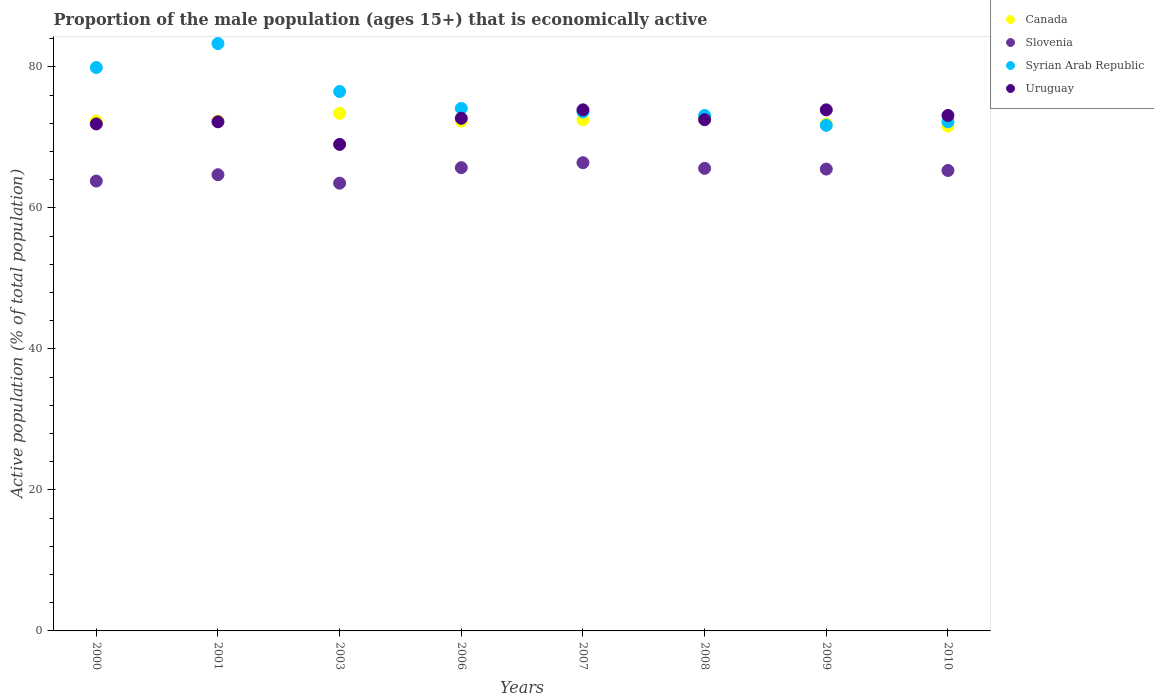Is the number of dotlines equal to the number of legend labels?
Offer a very short reply. Yes. What is the proportion of the male population that is economically active in Slovenia in 2006?
Your answer should be very brief. 65.7. Across all years, what is the maximum proportion of the male population that is economically active in Canada?
Provide a short and direct response. 73.4. Across all years, what is the minimum proportion of the male population that is economically active in Syrian Arab Republic?
Make the answer very short. 71.7. In which year was the proportion of the male population that is economically active in Uruguay minimum?
Your answer should be compact. 2003. What is the total proportion of the male population that is economically active in Slovenia in the graph?
Offer a very short reply. 520.5. What is the difference between the proportion of the male population that is economically active in Uruguay in 2000 and that in 2007?
Keep it short and to the point. -2. What is the difference between the proportion of the male population that is economically active in Uruguay in 2003 and the proportion of the male population that is economically active in Syrian Arab Republic in 2000?
Give a very brief answer. -10.9. What is the average proportion of the male population that is economically active in Syrian Arab Republic per year?
Your answer should be compact. 75.55. In the year 2007, what is the difference between the proportion of the male population that is economically active in Canada and proportion of the male population that is economically active in Uruguay?
Your answer should be compact. -1.4. What is the ratio of the proportion of the male population that is economically active in Slovenia in 2000 to that in 2003?
Your response must be concise. 1. What is the difference between the highest and the second highest proportion of the male population that is economically active in Syrian Arab Republic?
Offer a very short reply. 3.4. What is the difference between the highest and the lowest proportion of the male population that is economically active in Slovenia?
Your answer should be very brief. 2.9. In how many years, is the proportion of the male population that is economically active in Canada greater than the average proportion of the male population that is economically active in Canada taken over all years?
Ensure brevity in your answer.  3. Is the sum of the proportion of the male population that is economically active in Syrian Arab Republic in 2001 and 2007 greater than the maximum proportion of the male population that is economically active in Slovenia across all years?
Your response must be concise. Yes. Is it the case that in every year, the sum of the proportion of the male population that is economically active in Syrian Arab Republic and proportion of the male population that is economically active in Slovenia  is greater than the sum of proportion of the male population that is economically active in Canada and proportion of the male population that is economically active in Uruguay?
Your answer should be very brief. No. Is it the case that in every year, the sum of the proportion of the male population that is economically active in Syrian Arab Republic and proportion of the male population that is economically active in Uruguay  is greater than the proportion of the male population that is economically active in Canada?
Your response must be concise. Yes. Does the proportion of the male population that is economically active in Canada monotonically increase over the years?
Ensure brevity in your answer.  No. How many dotlines are there?
Offer a very short reply. 4. How many years are there in the graph?
Ensure brevity in your answer.  8. Are the values on the major ticks of Y-axis written in scientific E-notation?
Make the answer very short. No. Does the graph contain any zero values?
Give a very brief answer. No. How many legend labels are there?
Your answer should be very brief. 4. How are the legend labels stacked?
Provide a short and direct response. Vertical. What is the title of the graph?
Make the answer very short. Proportion of the male population (ages 15+) that is economically active. Does "Mauritania" appear as one of the legend labels in the graph?
Offer a terse response. No. What is the label or title of the Y-axis?
Provide a short and direct response. Active population (% of total population). What is the Active population (% of total population) of Canada in 2000?
Offer a terse response. 72.3. What is the Active population (% of total population) of Slovenia in 2000?
Offer a very short reply. 63.8. What is the Active population (% of total population) of Syrian Arab Republic in 2000?
Keep it short and to the point. 79.9. What is the Active population (% of total population) of Uruguay in 2000?
Make the answer very short. 71.9. What is the Active population (% of total population) in Canada in 2001?
Your answer should be very brief. 72.3. What is the Active population (% of total population) in Slovenia in 2001?
Keep it short and to the point. 64.7. What is the Active population (% of total population) in Syrian Arab Republic in 2001?
Make the answer very short. 83.3. What is the Active population (% of total population) of Uruguay in 2001?
Keep it short and to the point. 72.2. What is the Active population (% of total population) in Canada in 2003?
Make the answer very short. 73.4. What is the Active population (% of total population) of Slovenia in 2003?
Ensure brevity in your answer.  63.5. What is the Active population (% of total population) of Syrian Arab Republic in 2003?
Give a very brief answer. 76.5. What is the Active population (% of total population) in Uruguay in 2003?
Offer a very short reply. 69. What is the Active population (% of total population) of Canada in 2006?
Make the answer very short. 72.3. What is the Active population (% of total population) in Slovenia in 2006?
Your answer should be very brief. 65.7. What is the Active population (% of total population) in Syrian Arab Republic in 2006?
Offer a terse response. 74.1. What is the Active population (% of total population) in Uruguay in 2006?
Give a very brief answer. 72.7. What is the Active population (% of total population) of Canada in 2007?
Offer a very short reply. 72.5. What is the Active population (% of total population) in Slovenia in 2007?
Provide a succinct answer. 66.4. What is the Active population (% of total population) in Syrian Arab Republic in 2007?
Your answer should be very brief. 73.6. What is the Active population (% of total population) of Uruguay in 2007?
Make the answer very short. 73.9. What is the Active population (% of total population) of Canada in 2008?
Your answer should be very brief. 72.7. What is the Active population (% of total population) of Slovenia in 2008?
Give a very brief answer. 65.6. What is the Active population (% of total population) in Syrian Arab Republic in 2008?
Make the answer very short. 73.1. What is the Active population (% of total population) in Uruguay in 2008?
Your answer should be compact. 72.5. What is the Active population (% of total population) in Canada in 2009?
Offer a terse response. 71.9. What is the Active population (% of total population) in Slovenia in 2009?
Make the answer very short. 65.5. What is the Active population (% of total population) of Syrian Arab Republic in 2009?
Make the answer very short. 71.7. What is the Active population (% of total population) of Uruguay in 2009?
Your answer should be compact. 73.9. What is the Active population (% of total population) in Canada in 2010?
Ensure brevity in your answer.  71.6. What is the Active population (% of total population) of Slovenia in 2010?
Ensure brevity in your answer.  65.3. What is the Active population (% of total population) of Syrian Arab Republic in 2010?
Your answer should be compact. 72.2. What is the Active population (% of total population) of Uruguay in 2010?
Your answer should be very brief. 73.1. Across all years, what is the maximum Active population (% of total population) of Canada?
Provide a short and direct response. 73.4. Across all years, what is the maximum Active population (% of total population) in Slovenia?
Offer a terse response. 66.4. Across all years, what is the maximum Active population (% of total population) of Syrian Arab Republic?
Ensure brevity in your answer.  83.3. Across all years, what is the maximum Active population (% of total population) of Uruguay?
Keep it short and to the point. 73.9. Across all years, what is the minimum Active population (% of total population) of Canada?
Your response must be concise. 71.6. Across all years, what is the minimum Active population (% of total population) in Slovenia?
Give a very brief answer. 63.5. Across all years, what is the minimum Active population (% of total population) of Syrian Arab Republic?
Provide a short and direct response. 71.7. Across all years, what is the minimum Active population (% of total population) in Uruguay?
Provide a short and direct response. 69. What is the total Active population (% of total population) in Canada in the graph?
Provide a succinct answer. 579. What is the total Active population (% of total population) in Slovenia in the graph?
Ensure brevity in your answer.  520.5. What is the total Active population (% of total population) of Syrian Arab Republic in the graph?
Your response must be concise. 604.4. What is the total Active population (% of total population) in Uruguay in the graph?
Keep it short and to the point. 579.2. What is the difference between the Active population (% of total population) in Canada in 2000 and that in 2003?
Make the answer very short. -1.1. What is the difference between the Active population (% of total population) of Canada in 2000 and that in 2007?
Ensure brevity in your answer.  -0.2. What is the difference between the Active population (% of total population) in Slovenia in 2000 and that in 2007?
Provide a short and direct response. -2.6. What is the difference between the Active population (% of total population) in Canada in 2000 and that in 2008?
Give a very brief answer. -0.4. What is the difference between the Active population (% of total population) of Uruguay in 2000 and that in 2008?
Offer a terse response. -0.6. What is the difference between the Active population (% of total population) of Canada in 2000 and that in 2009?
Ensure brevity in your answer.  0.4. What is the difference between the Active population (% of total population) in Syrian Arab Republic in 2000 and that in 2009?
Provide a succinct answer. 8.2. What is the difference between the Active population (% of total population) in Uruguay in 2000 and that in 2009?
Provide a short and direct response. -2. What is the difference between the Active population (% of total population) in Slovenia in 2000 and that in 2010?
Ensure brevity in your answer.  -1.5. What is the difference between the Active population (% of total population) of Syrian Arab Republic in 2000 and that in 2010?
Provide a short and direct response. 7.7. What is the difference between the Active population (% of total population) in Uruguay in 2000 and that in 2010?
Ensure brevity in your answer.  -1.2. What is the difference between the Active population (% of total population) in Canada in 2001 and that in 2006?
Make the answer very short. 0. What is the difference between the Active population (% of total population) of Slovenia in 2001 and that in 2006?
Ensure brevity in your answer.  -1. What is the difference between the Active population (% of total population) of Canada in 2001 and that in 2007?
Provide a succinct answer. -0.2. What is the difference between the Active population (% of total population) in Slovenia in 2001 and that in 2007?
Offer a very short reply. -1.7. What is the difference between the Active population (% of total population) of Syrian Arab Republic in 2001 and that in 2008?
Provide a succinct answer. 10.2. What is the difference between the Active population (% of total population) in Canada in 2001 and that in 2009?
Make the answer very short. 0.4. What is the difference between the Active population (% of total population) of Syrian Arab Republic in 2001 and that in 2009?
Make the answer very short. 11.6. What is the difference between the Active population (% of total population) in Slovenia in 2001 and that in 2010?
Make the answer very short. -0.6. What is the difference between the Active population (% of total population) of Syrian Arab Republic in 2001 and that in 2010?
Keep it short and to the point. 11.1. What is the difference between the Active population (% of total population) in Slovenia in 2003 and that in 2006?
Keep it short and to the point. -2.2. What is the difference between the Active population (% of total population) in Syrian Arab Republic in 2003 and that in 2006?
Ensure brevity in your answer.  2.4. What is the difference between the Active population (% of total population) in Uruguay in 2003 and that in 2006?
Your answer should be compact. -3.7. What is the difference between the Active population (% of total population) of Slovenia in 2003 and that in 2007?
Your response must be concise. -2.9. What is the difference between the Active population (% of total population) of Syrian Arab Republic in 2003 and that in 2007?
Make the answer very short. 2.9. What is the difference between the Active population (% of total population) of Canada in 2003 and that in 2008?
Provide a succinct answer. 0.7. What is the difference between the Active population (% of total population) in Slovenia in 2003 and that in 2008?
Your response must be concise. -2.1. What is the difference between the Active population (% of total population) of Syrian Arab Republic in 2003 and that in 2008?
Provide a short and direct response. 3.4. What is the difference between the Active population (% of total population) of Uruguay in 2003 and that in 2009?
Keep it short and to the point. -4.9. What is the difference between the Active population (% of total population) in Canada in 2003 and that in 2010?
Your answer should be very brief. 1.8. What is the difference between the Active population (% of total population) of Uruguay in 2003 and that in 2010?
Give a very brief answer. -4.1. What is the difference between the Active population (% of total population) in Canada in 2006 and that in 2007?
Ensure brevity in your answer.  -0.2. What is the difference between the Active population (% of total population) in Slovenia in 2006 and that in 2007?
Ensure brevity in your answer.  -0.7. What is the difference between the Active population (% of total population) of Canada in 2006 and that in 2008?
Offer a very short reply. -0.4. What is the difference between the Active population (% of total population) of Slovenia in 2006 and that in 2008?
Offer a terse response. 0.1. What is the difference between the Active population (% of total population) of Uruguay in 2006 and that in 2008?
Make the answer very short. 0.2. What is the difference between the Active population (% of total population) in Canada in 2006 and that in 2009?
Give a very brief answer. 0.4. What is the difference between the Active population (% of total population) of Slovenia in 2006 and that in 2010?
Offer a terse response. 0.4. What is the difference between the Active population (% of total population) in Slovenia in 2007 and that in 2008?
Keep it short and to the point. 0.8. What is the difference between the Active population (% of total population) in Syrian Arab Republic in 2007 and that in 2008?
Offer a very short reply. 0.5. What is the difference between the Active population (% of total population) in Slovenia in 2007 and that in 2009?
Make the answer very short. 0.9. What is the difference between the Active population (% of total population) in Canada in 2007 and that in 2010?
Offer a terse response. 0.9. What is the difference between the Active population (% of total population) of Syrian Arab Republic in 2007 and that in 2010?
Provide a short and direct response. 1.4. What is the difference between the Active population (% of total population) in Uruguay in 2007 and that in 2010?
Your answer should be very brief. 0.8. What is the difference between the Active population (% of total population) in Slovenia in 2008 and that in 2009?
Offer a very short reply. 0.1. What is the difference between the Active population (% of total population) in Syrian Arab Republic in 2008 and that in 2009?
Your response must be concise. 1.4. What is the difference between the Active population (% of total population) of Uruguay in 2008 and that in 2009?
Your response must be concise. -1.4. What is the difference between the Active population (% of total population) in Canada in 2008 and that in 2010?
Give a very brief answer. 1.1. What is the difference between the Active population (% of total population) of Syrian Arab Republic in 2008 and that in 2010?
Your answer should be compact. 0.9. What is the difference between the Active population (% of total population) of Uruguay in 2008 and that in 2010?
Give a very brief answer. -0.6. What is the difference between the Active population (% of total population) in Slovenia in 2009 and that in 2010?
Keep it short and to the point. 0.2. What is the difference between the Active population (% of total population) in Canada in 2000 and the Active population (% of total population) in Syrian Arab Republic in 2001?
Your response must be concise. -11. What is the difference between the Active population (% of total population) in Slovenia in 2000 and the Active population (% of total population) in Syrian Arab Republic in 2001?
Keep it short and to the point. -19.5. What is the difference between the Active population (% of total population) in Slovenia in 2000 and the Active population (% of total population) in Uruguay in 2001?
Make the answer very short. -8.4. What is the difference between the Active population (% of total population) of Syrian Arab Republic in 2000 and the Active population (% of total population) of Uruguay in 2001?
Make the answer very short. 7.7. What is the difference between the Active population (% of total population) in Canada in 2000 and the Active population (% of total population) in Uruguay in 2003?
Your response must be concise. 3.3. What is the difference between the Active population (% of total population) of Syrian Arab Republic in 2000 and the Active population (% of total population) of Uruguay in 2003?
Keep it short and to the point. 10.9. What is the difference between the Active population (% of total population) in Canada in 2000 and the Active population (% of total population) in Syrian Arab Republic in 2006?
Make the answer very short. -1.8. What is the difference between the Active population (% of total population) of Canada in 2000 and the Active population (% of total population) of Uruguay in 2006?
Provide a succinct answer. -0.4. What is the difference between the Active population (% of total population) in Slovenia in 2000 and the Active population (% of total population) in Uruguay in 2006?
Make the answer very short. -8.9. What is the difference between the Active population (% of total population) in Syrian Arab Republic in 2000 and the Active population (% of total population) in Uruguay in 2006?
Ensure brevity in your answer.  7.2. What is the difference between the Active population (% of total population) of Canada in 2000 and the Active population (% of total population) of Slovenia in 2007?
Ensure brevity in your answer.  5.9. What is the difference between the Active population (% of total population) of Canada in 2000 and the Active population (% of total population) of Syrian Arab Republic in 2007?
Provide a short and direct response. -1.3. What is the difference between the Active population (% of total population) in Slovenia in 2000 and the Active population (% of total population) in Syrian Arab Republic in 2007?
Provide a succinct answer. -9.8. What is the difference between the Active population (% of total population) in Canada in 2000 and the Active population (% of total population) in Uruguay in 2008?
Give a very brief answer. -0.2. What is the difference between the Active population (% of total population) in Slovenia in 2000 and the Active population (% of total population) in Syrian Arab Republic in 2008?
Make the answer very short. -9.3. What is the difference between the Active population (% of total population) in Slovenia in 2000 and the Active population (% of total population) in Uruguay in 2008?
Make the answer very short. -8.7. What is the difference between the Active population (% of total population) of Canada in 2000 and the Active population (% of total population) of Slovenia in 2009?
Provide a short and direct response. 6.8. What is the difference between the Active population (% of total population) of Canada in 2000 and the Active population (% of total population) of Syrian Arab Republic in 2009?
Offer a terse response. 0.6. What is the difference between the Active population (% of total population) of Canada in 2000 and the Active population (% of total population) of Uruguay in 2009?
Make the answer very short. -1.6. What is the difference between the Active population (% of total population) of Slovenia in 2000 and the Active population (% of total population) of Uruguay in 2009?
Provide a short and direct response. -10.1. What is the difference between the Active population (% of total population) in Canada in 2000 and the Active population (% of total population) in Uruguay in 2010?
Offer a very short reply. -0.8. What is the difference between the Active population (% of total population) in Slovenia in 2000 and the Active population (% of total population) in Syrian Arab Republic in 2010?
Make the answer very short. -8.4. What is the difference between the Active population (% of total population) in Slovenia in 2000 and the Active population (% of total population) in Uruguay in 2010?
Make the answer very short. -9.3. What is the difference between the Active population (% of total population) in Canada in 2001 and the Active population (% of total population) in Slovenia in 2003?
Offer a terse response. 8.8. What is the difference between the Active population (% of total population) in Canada in 2001 and the Active population (% of total population) in Syrian Arab Republic in 2003?
Your answer should be compact. -4.2. What is the difference between the Active population (% of total population) of Syrian Arab Republic in 2001 and the Active population (% of total population) of Uruguay in 2003?
Keep it short and to the point. 14.3. What is the difference between the Active population (% of total population) of Slovenia in 2001 and the Active population (% of total population) of Syrian Arab Republic in 2006?
Provide a short and direct response. -9.4. What is the difference between the Active population (% of total population) in Syrian Arab Republic in 2001 and the Active population (% of total population) in Uruguay in 2006?
Give a very brief answer. 10.6. What is the difference between the Active population (% of total population) of Canada in 2001 and the Active population (% of total population) of Slovenia in 2007?
Offer a very short reply. 5.9. What is the difference between the Active population (% of total population) in Canada in 2001 and the Active population (% of total population) in Uruguay in 2007?
Provide a short and direct response. -1.6. What is the difference between the Active population (% of total population) in Slovenia in 2001 and the Active population (% of total population) in Syrian Arab Republic in 2007?
Provide a succinct answer. -8.9. What is the difference between the Active population (% of total population) of Canada in 2001 and the Active population (% of total population) of Syrian Arab Republic in 2008?
Offer a terse response. -0.8. What is the difference between the Active population (% of total population) in Slovenia in 2001 and the Active population (% of total population) in Uruguay in 2008?
Ensure brevity in your answer.  -7.8. What is the difference between the Active population (% of total population) of Canada in 2001 and the Active population (% of total population) of Slovenia in 2009?
Your answer should be very brief. 6.8. What is the difference between the Active population (% of total population) in Canada in 2001 and the Active population (% of total population) in Syrian Arab Republic in 2009?
Provide a short and direct response. 0.6. What is the difference between the Active population (% of total population) in Slovenia in 2001 and the Active population (% of total population) in Uruguay in 2009?
Ensure brevity in your answer.  -9.2. What is the difference between the Active population (% of total population) in Syrian Arab Republic in 2001 and the Active population (% of total population) in Uruguay in 2009?
Give a very brief answer. 9.4. What is the difference between the Active population (% of total population) of Canada in 2001 and the Active population (% of total population) of Uruguay in 2010?
Ensure brevity in your answer.  -0.8. What is the difference between the Active population (% of total population) of Slovenia in 2001 and the Active population (% of total population) of Syrian Arab Republic in 2010?
Offer a very short reply. -7.5. What is the difference between the Active population (% of total population) of Syrian Arab Republic in 2001 and the Active population (% of total population) of Uruguay in 2010?
Offer a very short reply. 10.2. What is the difference between the Active population (% of total population) in Canada in 2003 and the Active population (% of total population) in Uruguay in 2006?
Your answer should be very brief. 0.7. What is the difference between the Active population (% of total population) of Slovenia in 2003 and the Active population (% of total population) of Uruguay in 2006?
Give a very brief answer. -9.2. What is the difference between the Active population (% of total population) in Syrian Arab Republic in 2003 and the Active population (% of total population) in Uruguay in 2006?
Make the answer very short. 3.8. What is the difference between the Active population (% of total population) of Canada in 2003 and the Active population (% of total population) of Syrian Arab Republic in 2007?
Offer a very short reply. -0.2. What is the difference between the Active population (% of total population) of Canada in 2003 and the Active population (% of total population) of Uruguay in 2007?
Keep it short and to the point. -0.5. What is the difference between the Active population (% of total population) in Syrian Arab Republic in 2003 and the Active population (% of total population) in Uruguay in 2007?
Provide a succinct answer. 2.6. What is the difference between the Active population (% of total population) of Canada in 2003 and the Active population (% of total population) of Syrian Arab Republic in 2008?
Ensure brevity in your answer.  0.3. What is the difference between the Active population (% of total population) of Canada in 2003 and the Active population (% of total population) of Uruguay in 2008?
Keep it short and to the point. 0.9. What is the difference between the Active population (% of total population) of Slovenia in 2003 and the Active population (% of total population) of Uruguay in 2008?
Give a very brief answer. -9. What is the difference between the Active population (% of total population) of Syrian Arab Republic in 2003 and the Active population (% of total population) of Uruguay in 2008?
Ensure brevity in your answer.  4. What is the difference between the Active population (% of total population) of Canada in 2003 and the Active population (% of total population) of Slovenia in 2009?
Your answer should be very brief. 7.9. What is the difference between the Active population (% of total population) in Canada in 2003 and the Active population (% of total population) in Syrian Arab Republic in 2009?
Ensure brevity in your answer.  1.7. What is the difference between the Active population (% of total population) of Canada in 2003 and the Active population (% of total population) of Uruguay in 2009?
Offer a terse response. -0.5. What is the difference between the Active population (% of total population) in Slovenia in 2003 and the Active population (% of total population) in Syrian Arab Republic in 2009?
Offer a very short reply. -8.2. What is the difference between the Active population (% of total population) in Slovenia in 2003 and the Active population (% of total population) in Uruguay in 2009?
Your answer should be very brief. -10.4. What is the difference between the Active population (% of total population) of Syrian Arab Republic in 2003 and the Active population (% of total population) of Uruguay in 2010?
Give a very brief answer. 3.4. What is the difference between the Active population (% of total population) in Canada in 2006 and the Active population (% of total population) in Syrian Arab Republic in 2007?
Your answer should be very brief. -1.3. What is the difference between the Active population (% of total population) in Canada in 2006 and the Active population (% of total population) in Uruguay in 2007?
Your answer should be very brief. -1.6. What is the difference between the Active population (% of total population) in Slovenia in 2006 and the Active population (% of total population) in Syrian Arab Republic in 2007?
Provide a short and direct response. -7.9. What is the difference between the Active population (% of total population) of Canada in 2006 and the Active population (% of total population) of Slovenia in 2008?
Make the answer very short. 6.7. What is the difference between the Active population (% of total population) of Canada in 2006 and the Active population (% of total population) of Syrian Arab Republic in 2008?
Make the answer very short. -0.8. What is the difference between the Active population (% of total population) in Canada in 2006 and the Active population (% of total population) in Uruguay in 2008?
Provide a succinct answer. -0.2. What is the difference between the Active population (% of total population) of Slovenia in 2006 and the Active population (% of total population) of Syrian Arab Republic in 2008?
Make the answer very short. -7.4. What is the difference between the Active population (% of total population) in Canada in 2006 and the Active population (% of total population) in Slovenia in 2009?
Provide a succinct answer. 6.8. What is the difference between the Active population (% of total population) of Slovenia in 2006 and the Active population (% of total population) of Uruguay in 2009?
Your answer should be very brief. -8.2. What is the difference between the Active population (% of total population) of Canada in 2006 and the Active population (% of total population) of Slovenia in 2010?
Provide a short and direct response. 7. What is the difference between the Active population (% of total population) of Canada in 2006 and the Active population (% of total population) of Syrian Arab Republic in 2010?
Provide a succinct answer. 0.1. What is the difference between the Active population (% of total population) in Canada in 2006 and the Active population (% of total population) in Uruguay in 2010?
Give a very brief answer. -0.8. What is the difference between the Active population (% of total population) in Slovenia in 2006 and the Active population (% of total population) in Syrian Arab Republic in 2010?
Keep it short and to the point. -6.5. What is the difference between the Active population (% of total population) in Canada in 2007 and the Active population (% of total population) in Slovenia in 2008?
Your answer should be very brief. 6.9. What is the difference between the Active population (% of total population) in Slovenia in 2007 and the Active population (% of total population) in Uruguay in 2008?
Make the answer very short. -6.1. What is the difference between the Active population (% of total population) of Syrian Arab Republic in 2007 and the Active population (% of total population) of Uruguay in 2008?
Keep it short and to the point. 1.1. What is the difference between the Active population (% of total population) in Canada in 2007 and the Active population (% of total population) in Slovenia in 2009?
Make the answer very short. 7. What is the difference between the Active population (% of total population) of Canada in 2007 and the Active population (% of total population) of Syrian Arab Republic in 2009?
Your answer should be very brief. 0.8. What is the difference between the Active population (% of total population) in Canada in 2007 and the Active population (% of total population) in Uruguay in 2009?
Ensure brevity in your answer.  -1.4. What is the difference between the Active population (% of total population) in Slovenia in 2007 and the Active population (% of total population) in Syrian Arab Republic in 2009?
Make the answer very short. -5.3. What is the difference between the Active population (% of total population) in Canada in 2007 and the Active population (% of total population) in Slovenia in 2010?
Offer a very short reply. 7.2. What is the difference between the Active population (% of total population) in Slovenia in 2007 and the Active population (% of total population) in Syrian Arab Republic in 2010?
Your response must be concise. -5.8. What is the difference between the Active population (% of total population) in Syrian Arab Republic in 2007 and the Active population (% of total population) in Uruguay in 2010?
Keep it short and to the point. 0.5. What is the difference between the Active population (% of total population) of Canada in 2008 and the Active population (% of total population) of Slovenia in 2009?
Offer a very short reply. 7.2. What is the difference between the Active population (% of total population) of Canada in 2008 and the Active population (% of total population) of Syrian Arab Republic in 2009?
Your answer should be compact. 1. What is the difference between the Active population (% of total population) of Canada in 2008 and the Active population (% of total population) of Uruguay in 2009?
Your answer should be very brief. -1.2. What is the difference between the Active population (% of total population) in Slovenia in 2008 and the Active population (% of total population) in Syrian Arab Republic in 2009?
Give a very brief answer. -6.1. What is the difference between the Active population (% of total population) of Slovenia in 2008 and the Active population (% of total population) of Uruguay in 2009?
Offer a very short reply. -8.3. What is the difference between the Active population (% of total population) of Syrian Arab Republic in 2008 and the Active population (% of total population) of Uruguay in 2009?
Make the answer very short. -0.8. What is the difference between the Active population (% of total population) of Canada in 2008 and the Active population (% of total population) of Syrian Arab Republic in 2010?
Provide a short and direct response. 0.5. What is the difference between the Active population (% of total population) of Syrian Arab Republic in 2008 and the Active population (% of total population) of Uruguay in 2010?
Offer a very short reply. 0. What is the difference between the Active population (% of total population) in Canada in 2009 and the Active population (% of total population) in Slovenia in 2010?
Provide a short and direct response. 6.6. What is the average Active population (% of total population) in Canada per year?
Your answer should be very brief. 72.38. What is the average Active population (% of total population) in Slovenia per year?
Give a very brief answer. 65.06. What is the average Active population (% of total population) of Syrian Arab Republic per year?
Offer a very short reply. 75.55. What is the average Active population (% of total population) in Uruguay per year?
Give a very brief answer. 72.4. In the year 2000, what is the difference between the Active population (% of total population) of Canada and Active population (% of total population) of Syrian Arab Republic?
Provide a short and direct response. -7.6. In the year 2000, what is the difference between the Active population (% of total population) of Canada and Active population (% of total population) of Uruguay?
Your answer should be very brief. 0.4. In the year 2000, what is the difference between the Active population (% of total population) of Slovenia and Active population (% of total population) of Syrian Arab Republic?
Offer a terse response. -16.1. In the year 2000, what is the difference between the Active population (% of total population) of Slovenia and Active population (% of total population) of Uruguay?
Give a very brief answer. -8.1. In the year 2001, what is the difference between the Active population (% of total population) of Canada and Active population (% of total population) of Syrian Arab Republic?
Give a very brief answer. -11. In the year 2001, what is the difference between the Active population (% of total population) in Slovenia and Active population (% of total population) in Syrian Arab Republic?
Your response must be concise. -18.6. In the year 2003, what is the difference between the Active population (% of total population) in Canada and Active population (% of total population) in Syrian Arab Republic?
Make the answer very short. -3.1. In the year 2003, what is the difference between the Active population (% of total population) of Canada and Active population (% of total population) of Uruguay?
Your answer should be very brief. 4.4. In the year 2003, what is the difference between the Active population (% of total population) in Syrian Arab Republic and Active population (% of total population) in Uruguay?
Provide a short and direct response. 7.5. In the year 2006, what is the difference between the Active population (% of total population) of Canada and Active population (% of total population) of Syrian Arab Republic?
Provide a succinct answer. -1.8. In the year 2006, what is the difference between the Active population (% of total population) of Slovenia and Active population (% of total population) of Syrian Arab Republic?
Provide a succinct answer. -8.4. In the year 2006, what is the difference between the Active population (% of total population) of Slovenia and Active population (% of total population) of Uruguay?
Provide a succinct answer. -7. In the year 2007, what is the difference between the Active population (% of total population) of Canada and Active population (% of total population) of Slovenia?
Keep it short and to the point. 6.1. In the year 2007, what is the difference between the Active population (% of total population) of Canada and Active population (% of total population) of Uruguay?
Your answer should be very brief. -1.4. In the year 2007, what is the difference between the Active population (% of total population) in Slovenia and Active population (% of total population) in Syrian Arab Republic?
Offer a terse response. -7.2. In the year 2008, what is the difference between the Active population (% of total population) of Canada and Active population (% of total population) of Syrian Arab Republic?
Provide a short and direct response. -0.4. In the year 2008, what is the difference between the Active population (% of total population) of Canada and Active population (% of total population) of Uruguay?
Provide a short and direct response. 0.2. In the year 2008, what is the difference between the Active population (% of total population) of Slovenia and Active population (% of total population) of Syrian Arab Republic?
Ensure brevity in your answer.  -7.5. In the year 2009, what is the difference between the Active population (% of total population) in Canada and Active population (% of total population) in Slovenia?
Give a very brief answer. 6.4. In the year 2010, what is the difference between the Active population (% of total population) of Canada and Active population (% of total population) of Slovenia?
Your answer should be compact. 6.3. In the year 2010, what is the difference between the Active population (% of total population) in Canada and Active population (% of total population) in Syrian Arab Republic?
Provide a short and direct response. -0.6. In the year 2010, what is the difference between the Active population (% of total population) in Canada and Active population (% of total population) in Uruguay?
Ensure brevity in your answer.  -1.5. In the year 2010, what is the difference between the Active population (% of total population) of Slovenia and Active population (% of total population) of Uruguay?
Provide a succinct answer. -7.8. What is the ratio of the Active population (% of total population) in Canada in 2000 to that in 2001?
Your answer should be very brief. 1. What is the ratio of the Active population (% of total population) of Slovenia in 2000 to that in 2001?
Give a very brief answer. 0.99. What is the ratio of the Active population (% of total population) of Syrian Arab Republic in 2000 to that in 2001?
Your response must be concise. 0.96. What is the ratio of the Active population (% of total population) of Uruguay in 2000 to that in 2001?
Provide a succinct answer. 1. What is the ratio of the Active population (% of total population) in Syrian Arab Republic in 2000 to that in 2003?
Ensure brevity in your answer.  1.04. What is the ratio of the Active population (% of total population) of Uruguay in 2000 to that in 2003?
Your answer should be very brief. 1.04. What is the ratio of the Active population (% of total population) of Slovenia in 2000 to that in 2006?
Make the answer very short. 0.97. What is the ratio of the Active population (% of total population) of Syrian Arab Republic in 2000 to that in 2006?
Your answer should be very brief. 1.08. What is the ratio of the Active population (% of total population) in Slovenia in 2000 to that in 2007?
Your answer should be very brief. 0.96. What is the ratio of the Active population (% of total population) in Syrian Arab Republic in 2000 to that in 2007?
Offer a very short reply. 1.09. What is the ratio of the Active population (% of total population) in Uruguay in 2000 to that in 2007?
Ensure brevity in your answer.  0.97. What is the ratio of the Active population (% of total population) in Canada in 2000 to that in 2008?
Provide a short and direct response. 0.99. What is the ratio of the Active population (% of total population) in Slovenia in 2000 to that in 2008?
Offer a very short reply. 0.97. What is the ratio of the Active population (% of total population) of Syrian Arab Republic in 2000 to that in 2008?
Your answer should be compact. 1.09. What is the ratio of the Active population (% of total population) in Uruguay in 2000 to that in 2008?
Offer a very short reply. 0.99. What is the ratio of the Active population (% of total population) of Canada in 2000 to that in 2009?
Your answer should be very brief. 1.01. What is the ratio of the Active population (% of total population) in Syrian Arab Republic in 2000 to that in 2009?
Make the answer very short. 1.11. What is the ratio of the Active population (% of total population) in Uruguay in 2000 to that in 2009?
Give a very brief answer. 0.97. What is the ratio of the Active population (% of total population) of Canada in 2000 to that in 2010?
Offer a very short reply. 1.01. What is the ratio of the Active population (% of total population) in Slovenia in 2000 to that in 2010?
Provide a succinct answer. 0.98. What is the ratio of the Active population (% of total population) in Syrian Arab Republic in 2000 to that in 2010?
Keep it short and to the point. 1.11. What is the ratio of the Active population (% of total population) of Uruguay in 2000 to that in 2010?
Keep it short and to the point. 0.98. What is the ratio of the Active population (% of total population) in Slovenia in 2001 to that in 2003?
Provide a short and direct response. 1.02. What is the ratio of the Active population (% of total population) in Syrian Arab Republic in 2001 to that in 2003?
Offer a very short reply. 1.09. What is the ratio of the Active population (% of total population) of Uruguay in 2001 to that in 2003?
Provide a short and direct response. 1.05. What is the ratio of the Active population (% of total population) in Canada in 2001 to that in 2006?
Give a very brief answer. 1. What is the ratio of the Active population (% of total population) in Syrian Arab Republic in 2001 to that in 2006?
Provide a short and direct response. 1.12. What is the ratio of the Active population (% of total population) in Uruguay in 2001 to that in 2006?
Ensure brevity in your answer.  0.99. What is the ratio of the Active population (% of total population) in Canada in 2001 to that in 2007?
Make the answer very short. 1. What is the ratio of the Active population (% of total population) in Slovenia in 2001 to that in 2007?
Keep it short and to the point. 0.97. What is the ratio of the Active population (% of total population) of Syrian Arab Republic in 2001 to that in 2007?
Provide a short and direct response. 1.13. What is the ratio of the Active population (% of total population) in Uruguay in 2001 to that in 2007?
Provide a succinct answer. 0.98. What is the ratio of the Active population (% of total population) of Slovenia in 2001 to that in 2008?
Provide a succinct answer. 0.99. What is the ratio of the Active population (% of total population) of Syrian Arab Republic in 2001 to that in 2008?
Make the answer very short. 1.14. What is the ratio of the Active population (% of total population) of Uruguay in 2001 to that in 2008?
Provide a succinct answer. 1. What is the ratio of the Active population (% of total population) in Canada in 2001 to that in 2009?
Offer a very short reply. 1.01. What is the ratio of the Active population (% of total population) of Slovenia in 2001 to that in 2009?
Make the answer very short. 0.99. What is the ratio of the Active population (% of total population) in Syrian Arab Republic in 2001 to that in 2009?
Make the answer very short. 1.16. What is the ratio of the Active population (% of total population) of Canada in 2001 to that in 2010?
Provide a succinct answer. 1.01. What is the ratio of the Active population (% of total population) in Slovenia in 2001 to that in 2010?
Keep it short and to the point. 0.99. What is the ratio of the Active population (% of total population) in Syrian Arab Republic in 2001 to that in 2010?
Offer a very short reply. 1.15. What is the ratio of the Active population (% of total population) in Canada in 2003 to that in 2006?
Make the answer very short. 1.02. What is the ratio of the Active population (% of total population) in Slovenia in 2003 to that in 2006?
Your response must be concise. 0.97. What is the ratio of the Active population (% of total population) of Syrian Arab Republic in 2003 to that in 2006?
Make the answer very short. 1.03. What is the ratio of the Active population (% of total population) of Uruguay in 2003 to that in 2006?
Provide a short and direct response. 0.95. What is the ratio of the Active population (% of total population) of Canada in 2003 to that in 2007?
Keep it short and to the point. 1.01. What is the ratio of the Active population (% of total population) in Slovenia in 2003 to that in 2007?
Offer a very short reply. 0.96. What is the ratio of the Active population (% of total population) in Syrian Arab Republic in 2003 to that in 2007?
Your answer should be very brief. 1.04. What is the ratio of the Active population (% of total population) in Uruguay in 2003 to that in 2007?
Offer a terse response. 0.93. What is the ratio of the Active population (% of total population) in Canada in 2003 to that in 2008?
Your answer should be very brief. 1.01. What is the ratio of the Active population (% of total population) of Slovenia in 2003 to that in 2008?
Keep it short and to the point. 0.97. What is the ratio of the Active population (% of total population) in Syrian Arab Republic in 2003 to that in 2008?
Offer a terse response. 1.05. What is the ratio of the Active population (% of total population) in Uruguay in 2003 to that in 2008?
Offer a terse response. 0.95. What is the ratio of the Active population (% of total population) in Canada in 2003 to that in 2009?
Your answer should be compact. 1.02. What is the ratio of the Active population (% of total population) of Slovenia in 2003 to that in 2009?
Ensure brevity in your answer.  0.97. What is the ratio of the Active population (% of total population) of Syrian Arab Republic in 2003 to that in 2009?
Provide a succinct answer. 1.07. What is the ratio of the Active population (% of total population) of Uruguay in 2003 to that in 2009?
Your response must be concise. 0.93. What is the ratio of the Active population (% of total population) of Canada in 2003 to that in 2010?
Make the answer very short. 1.03. What is the ratio of the Active population (% of total population) of Slovenia in 2003 to that in 2010?
Your response must be concise. 0.97. What is the ratio of the Active population (% of total population) of Syrian Arab Republic in 2003 to that in 2010?
Ensure brevity in your answer.  1.06. What is the ratio of the Active population (% of total population) in Uruguay in 2003 to that in 2010?
Provide a succinct answer. 0.94. What is the ratio of the Active population (% of total population) of Canada in 2006 to that in 2007?
Offer a very short reply. 1. What is the ratio of the Active population (% of total population) of Syrian Arab Republic in 2006 to that in 2007?
Make the answer very short. 1.01. What is the ratio of the Active population (% of total population) of Uruguay in 2006 to that in 2007?
Your answer should be compact. 0.98. What is the ratio of the Active population (% of total population) of Canada in 2006 to that in 2008?
Ensure brevity in your answer.  0.99. What is the ratio of the Active population (% of total population) in Slovenia in 2006 to that in 2008?
Offer a terse response. 1. What is the ratio of the Active population (% of total population) in Syrian Arab Republic in 2006 to that in 2008?
Ensure brevity in your answer.  1.01. What is the ratio of the Active population (% of total population) in Canada in 2006 to that in 2009?
Give a very brief answer. 1.01. What is the ratio of the Active population (% of total population) in Syrian Arab Republic in 2006 to that in 2009?
Keep it short and to the point. 1.03. What is the ratio of the Active population (% of total population) in Uruguay in 2006 to that in 2009?
Your answer should be very brief. 0.98. What is the ratio of the Active population (% of total population) of Canada in 2006 to that in 2010?
Offer a terse response. 1.01. What is the ratio of the Active population (% of total population) of Slovenia in 2006 to that in 2010?
Give a very brief answer. 1.01. What is the ratio of the Active population (% of total population) in Syrian Arab Republic in 2006 to that in 2010?
Your response must be concise. 1.03. What is the ratio of the Active population (% of total population) in Uruguay in 2006 to that in 2010?
Provide a succinct answer. 0.99. What is the ratio of the Active population (% of total population) in Slovenia in 2007 to that in 2008?
Offer a very short reply. 1.01. What is the ratio of the Active population (% of total population) of Syrian Arab Republic in 2007 to that in 2008?
Give a very brief answer. 1.01. What is the ratio of the Active population (% of total population) of Uruguay in 2007 to that in 2008?
Offer a terse response. 1.02. What is the ratio of the Active population (% of total population) in Canada in 2007 to that in 2009?
Your answer should be very brief. 1.01. What is the ratio of the Active population (% of total population) in Slovenia in 2007 to that in 2009?
Ensure brevity in your answer.  1.01. What is the ratio of the Active population (% of total population) of Syrian Arab Republic in 2007 to that in 2009?
Offer a terse response. 1.03. What is the ratio of the Active population (% of total population) of Canada in 2007 to that in 2010?
Your answer should be very brief. 1.01. What is the ratio of the Active population (% of total population) in Slovenia in 2007 to that in 2010?
Offer a very short reply. 1.02. What is the ratio of the Active population (% of total population) in Syrian Arab Republic in 2007 to that in 2010?
Your answer should be very brief. 1.02. What is the ratio of the Active population (% of total population) of Uruguay in 2007 to that in 2010?
Ensure brevity in your answer.  1.01. What is the ratio of the Active population (% of total population) in Canada in 2008 to that in 2009?
Make the answer very short. 1.01. What is the ratio of the Active population (% of total population) in Slovenia in 2008 to that in 2009?
Your answer should be compact. 1. What is the ratio of the Active population (% of total population) of Syrian Arab Republic in 2008 to that in 2009?
Offer a very short reply. 1.02. What is the ratio of the Active population (% of total population) of Uruguay in 2008 to that in 2009?
Keep it short and to the point. 0.98. What is the ratio of the Active population (% of total population) of Canada in 2008 to that in 2010?
Ensure brevity in your answer.  1.02. What is the ratio of the Active population (% of total population) of Slovenia in 2008 to that in 2010?
Offer a very short reply. 1. What is the ratio of the Active population (% of total population) of Syrian Arab Republic in 2008 to that in 2010?
Offer a very short reply. 1.01. What is the ratio of the Active population (% of total population) in Uruguay in 2008 to that in 2010?
Provide a succinct answer. 0.99. What is the ratio of the Active population (% of total population) of Canada in 2009 to that in 2010?
Your response must be concise. 1. What is the ratio of the Active population (% of total population) of Syrian Arab Republic in 2009 to that in 2010?
Your response must be concise. 0.99. What is the ratio of the Active population (% of total population) in Uruguay in 2009 to that in 2010?
Provide a succinct answer. 1.01. What is the difference between the highest and the second highest Active population (% of total population) in Slovenia?
Your answer should be very brief. 0.7. What is the difference between the highest and the lowest Active population (% of total population) of Slovenia?
Your answer should be compact. 2.9. What is the difference between the highest and the lowest Active population (% of total population) in Syrian Arab Republic?
Ensure brevity in your answer.  11.6. What is the difference between the highest and the lowest Active population (% of total population) of Uruguay?
Your answer should be compact. 4.9. 